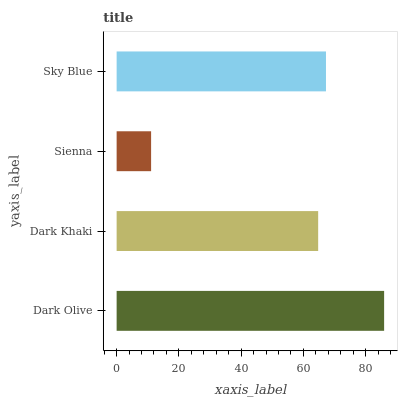Is Sienna the minimum?
Answer yes or no. Yes. Is Dark Olive the maximum?
Answer yes or no. Yes. Is Dark Khaki the minimum?
Answer yes or no. No. Is Dark Khaki the maximum?
Answer yes or no. No. Is Dark Olive greater than Dark Khaki?
Answer yes or no. Yes. Is Dark Khaki less than Dark Olive?
Answer yes or no. Yes. Is Dark Khaki greater than Dark Olive?
Answer yes or no. No. Is Dark Olive less than Dark Khaki?
Answer yes or no. No. Is Sky Blue the high median?
Answer yes or no. Yes. Is Dark Khaki the low median?
Answer yes or no. Yes. Is Sienna the high median?
Answer yes or no. No. Is Sienna the low median?
Answer yes or no. No. 